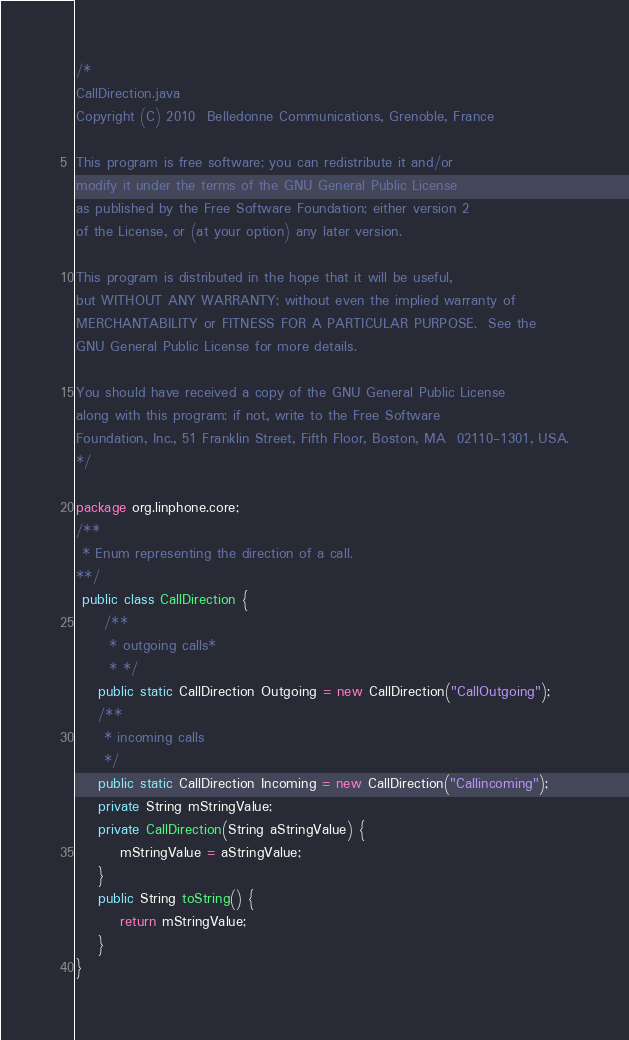Convert code to text. <code><loc_0><loc_0><loc_500><loc_500><_Java_>/*
CallDirection.java
Copyright (C) 2010  Belledonne Communications, Grenoble, France

This program is free software; you can redistribute it and/or
modify it under the terms of the GNU General Public License
as published by the Free Software Foundation; either version 2
of the License, or (at your option) any later version.

This program is distributed in the hope that it will be useful,
but WITHOUT ANY WARRANTY; without even the implied warranty of
MERCHANTABILITY or FITNESS FOR A PARTICULAR PURPOSE.  See the
GNU General Public License for more details.

You should have received a copy of the GNU General Public License
along with this program; if not, write to the Free Software
Foundation, Inc., 51 Franklin Street, Fifth Floor, Boston, MA  02110-1301, USA.
*/

package org.linphone.core;
/**
 * Enum representing the direction of a call.
**/
 public class CallDirection {
	 /**
	  * outgoing calls*
	  * */
	public static CallDirection Outgoing = new CallDirection("CallOutgoing");
	/**
	 * incoming calls
	 */
	public static CallDirection Incoming = new CallDirection("Callincoming");
	private String mStringValue;
	private CallDirection(String aStringValue) {
		mStringValue = aStringValue;
	}
	public String toString() {
		return mStringValue;
	}
}
</code> 